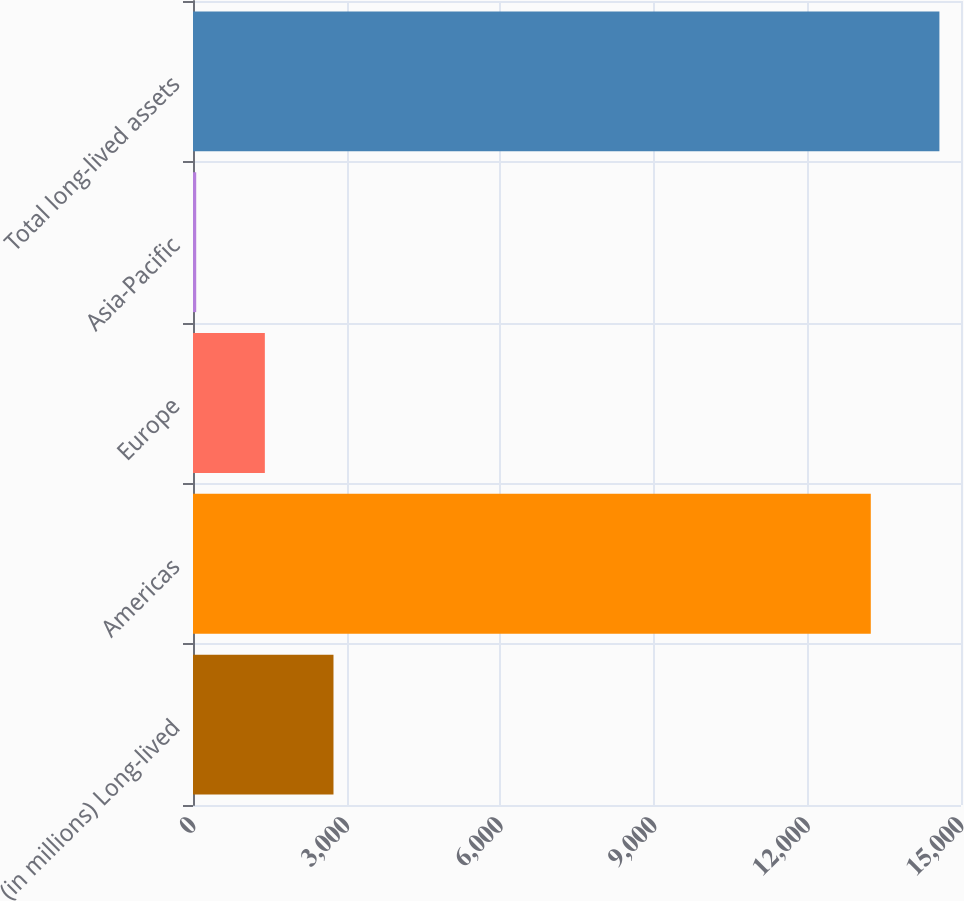Convert chart to OTSL. <chart><loc_0><loc_0><loc_500><loc_500><bar_chart><fcel>(in millions) Long-lived<fcel>Americas<fcel>Europe<fcel>Asia-Pacific<fcel>Total long-lived assets<nl><fcel>2743.8<fcel>13238<fcel>1403.4<fcel>63<fcel>14578.4<nl></chart> 